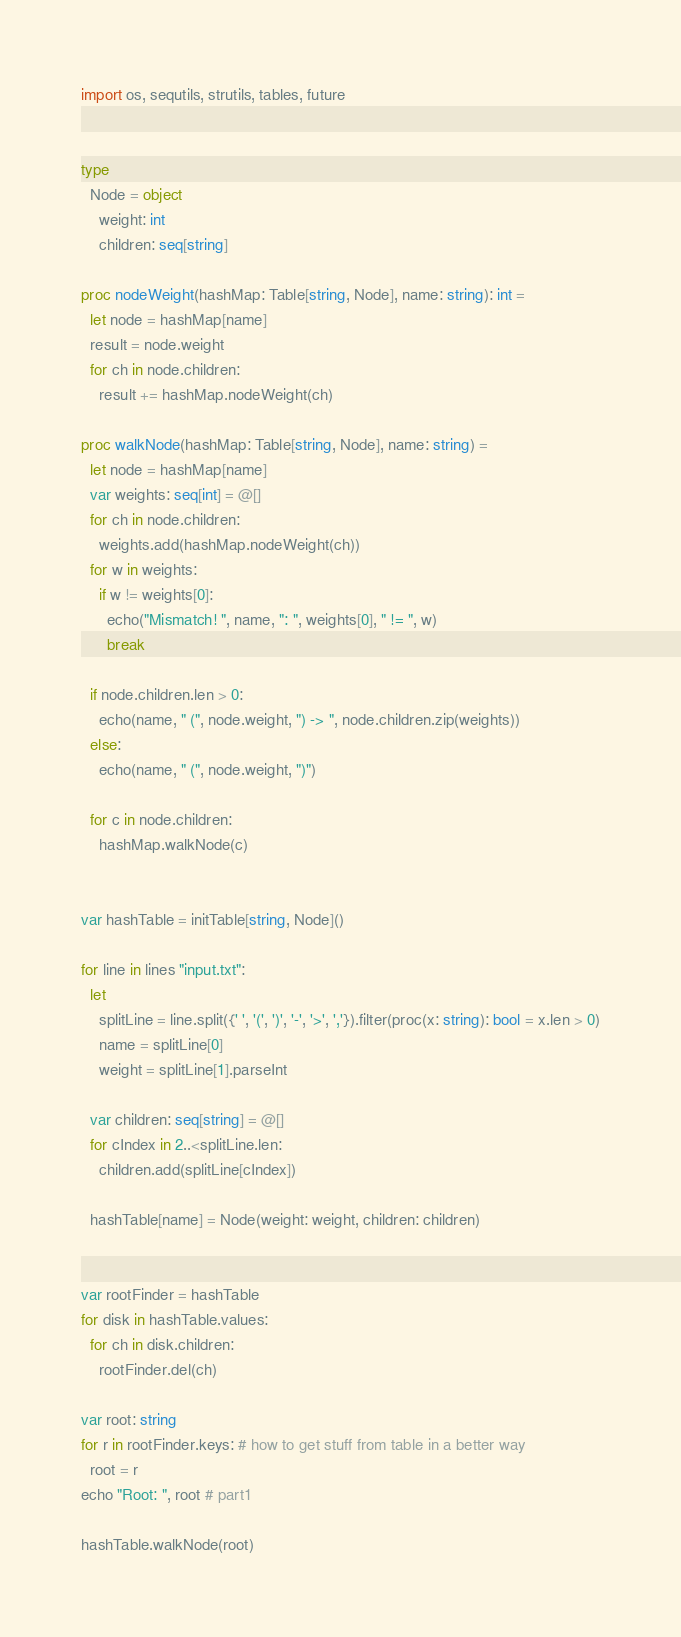Convert code to text. <code><loc_0><loc_0><loc_500><loc_500><_Nim_>import os, sequtils, strutils, tables, future


type
  Node = object
    weight: int
    children: seq[string]

proc nodeWeight(hashMap: Table[string, Node], name: string): int =
  let node = hashMap[name]
  result = node.weight
  for ch in node.children:
    result += hashMap.nodeWeight(ch)

proc walkNode(hashMap: Table[string, Node], name: string) =
  let node = hashMap[name]
  var weights: seq[int] = @[]
  for ch in node.children:
    weights.add(hashMap.nodeWeight(ch))
  for w in weights:
    if w != weights[0]:
      echo("Mismatch! ", name, ": ", weights[0], " != ", w)
      break

  if node.children.len > 0:
    echo(name, " (", node.weight, ") -> ", node.children.zip(weights))
  else:
    echo(name, " (", node.weight, ")")

  for c in node.children:
    hashMap.walkNode(c)


var hashTable = initTable[string, Node]()

for line in lines "input.txt":
  let
    splitLine = line.split({' ', '(', ')', '-', '>', ','}).filter(proc(x: string): bool = x.len > 0)
    name = splitLine[0]
    weight = splitLine[1].parseInt

  var children: seq[string] = @[]
  for cIndex in 2..<splitLine.len:
    children.add(splitLine[cIndex])

  hashTable[name] = Node(weight: weight, children: children)


var rootFinder = hashTable
for disk in hashTable.values:
  for ch in disk.children:
    rootFinder.del(ch)

var root: string
for r in rootFinder.keys: # how to get stuff from table in a better way
  root = r
echo "Root: ", root # part1

hashTable.walkNode(root)</code> 